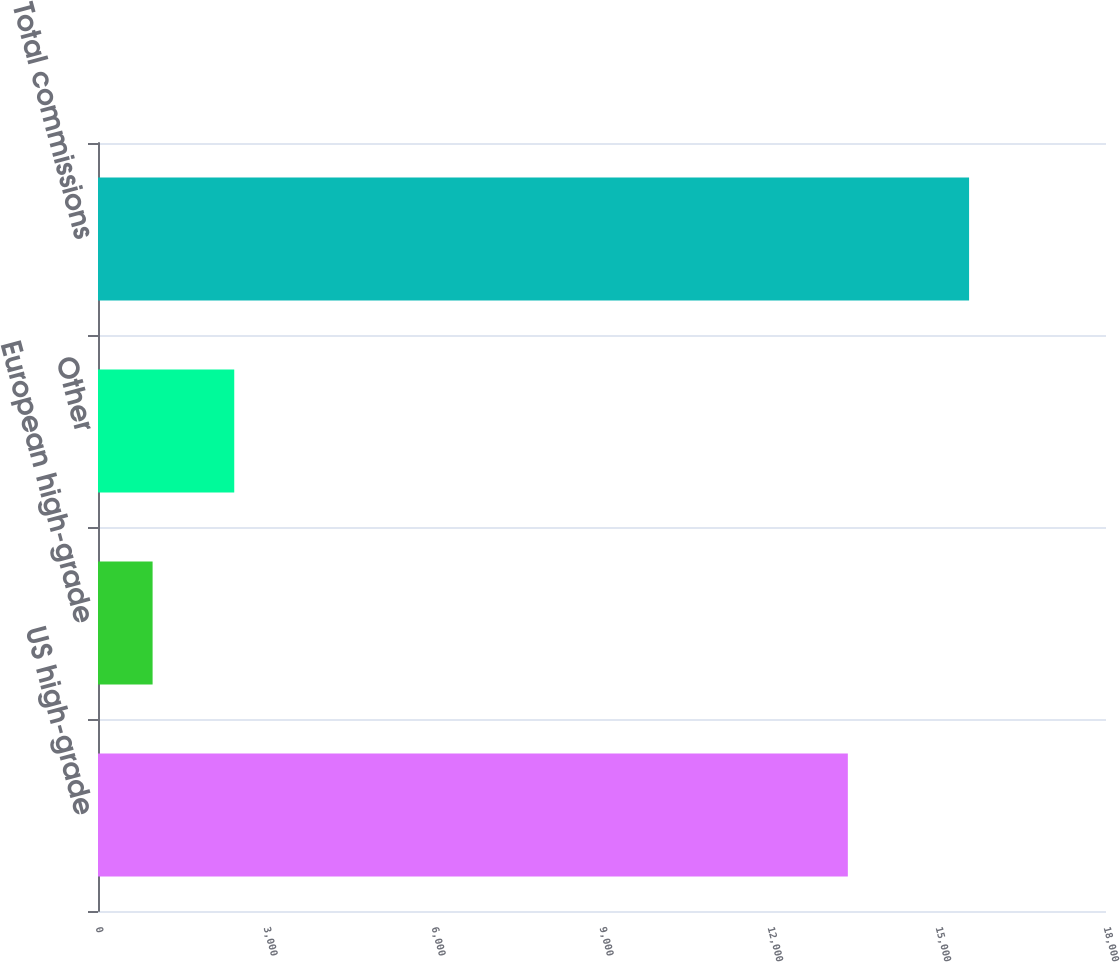<chart> <loc_0><loc_0><loc_500><loc_500><bar_chart><fcel>US high-grade<fcel>European high-grade<fcel>Other<fcel>Total commissions<nl><fcel>13390<fcel>975<fcel>2433<fcel>15555<nl></chart> 